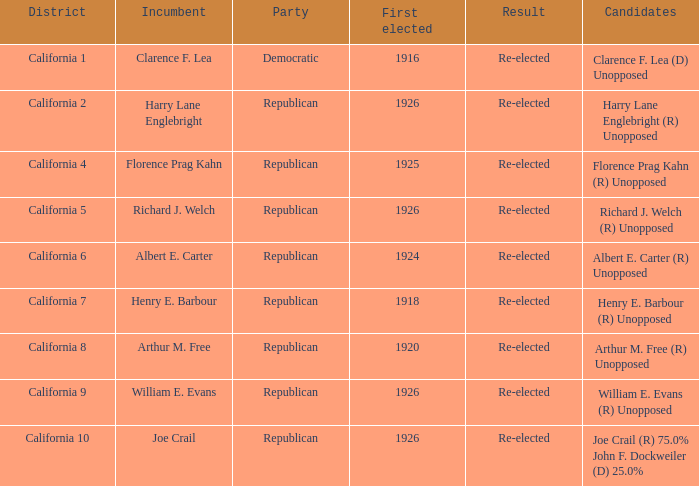In what district does harry lane englebright (r) run unopposed? California 2. 